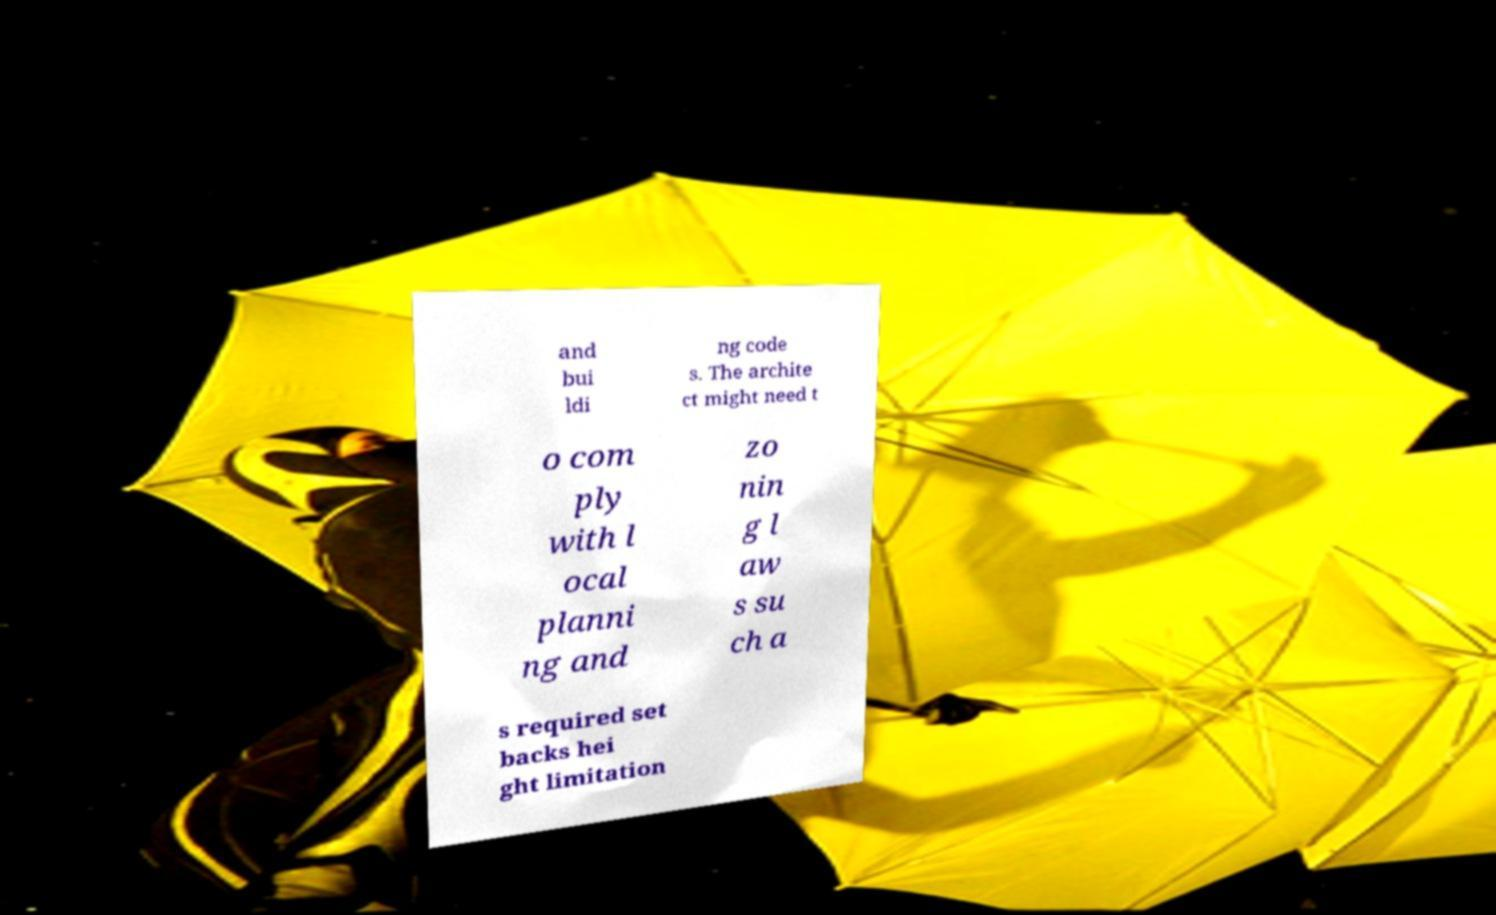I need the written content from this picture converted into text. Can you do that? and bui ldi ng code s. The archite ct might need t o com ply with l ocal planni ng and zo nin g l aw s su ch a s required set backs hei ght limitation 